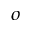<formula> <loc_0><loc_0><loc_500><loc_500>^ { o }</formula> 